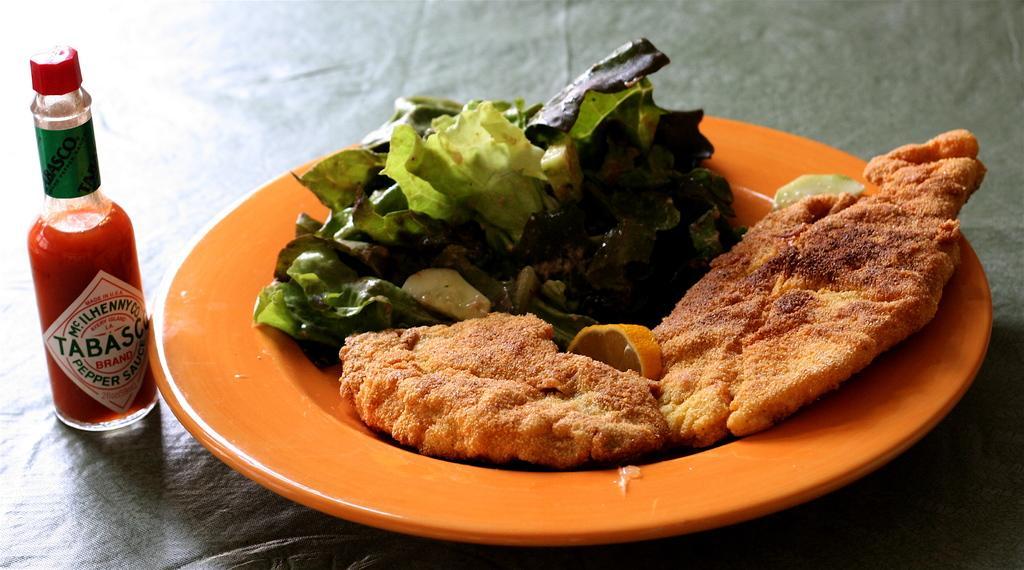In one or two sentences, can you explain what this image depicts? In this picture we can see some food item placed in the plate, side we can see one bottle. 